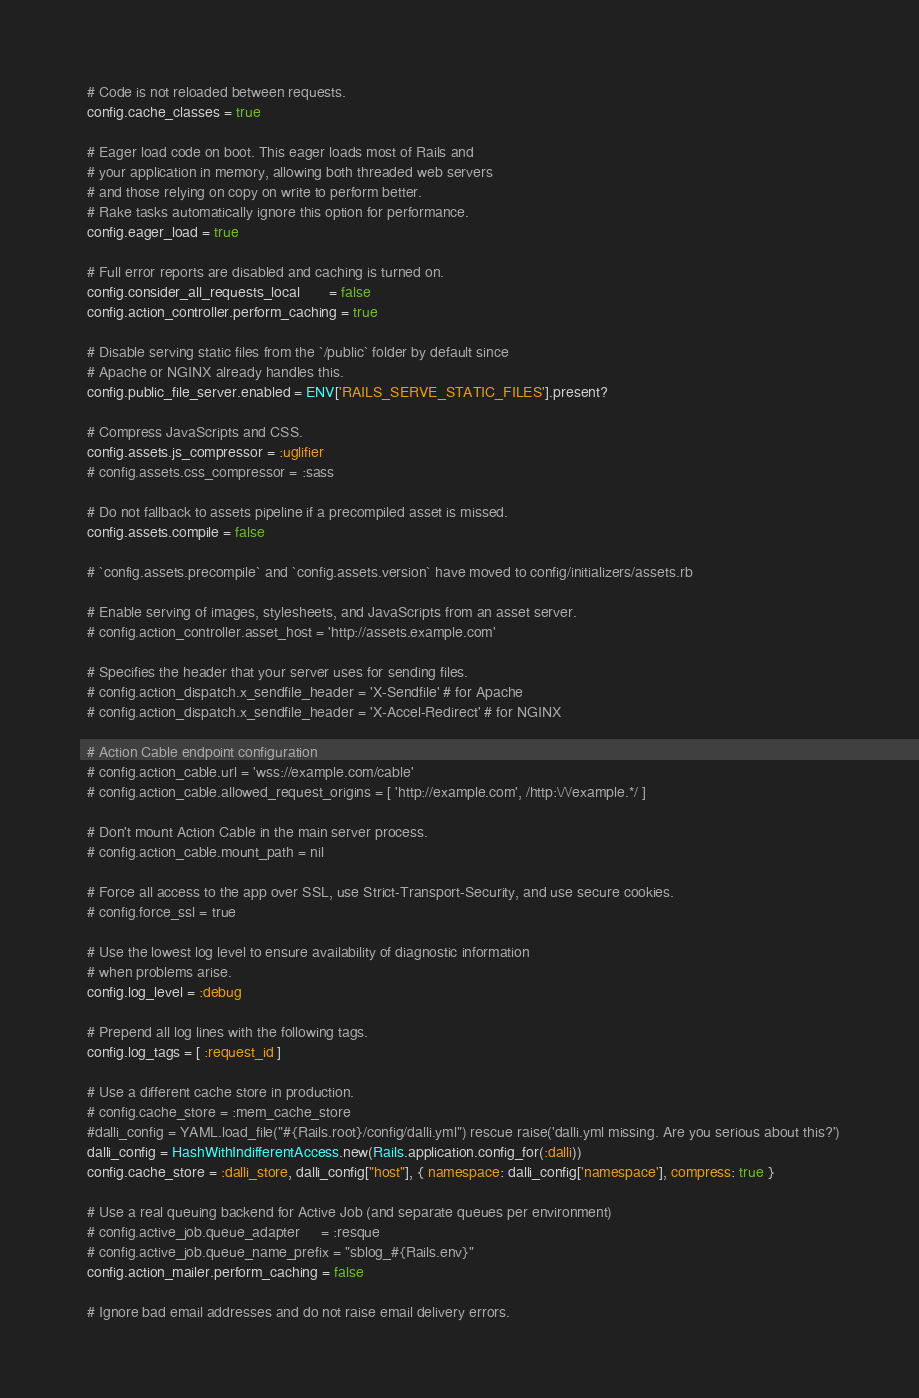<code> <loc_0><loc_0><loc_500><loc_500><_Ruby_>  # Code is not reloaded between requests.
  config.cache_classes = true

  # Eager load code on boot. This eager loads most of Rails and
  # your application in memory, allowing both threaded web servers
  # and those relying on copy on write to perform better.
  # Rake tasks automatically ignore this option for performance.
  config.eager_load = true

  # Full error reports are disabled and caching is turned on.
  config.consider_all_requests_local       = false
  config.action_controller.perform_caching = true

  # Disable serving static files from the `/public` folder by default since
  # Apache or NGINX already handles this.
  config.public_file_server.enabled = ENV['RAILS_SERVE_STATIC_FILES'].present?

  # Compress JavaScripts and CSS.
  config.assets.js_compressor = :uglifier
  # config.assets.css_compressor = :sass

  # Do not fallback to assets pipeline if a precompiled asset is missed.
  config.assets.compile = false

  # `config.assets.precompile` and `config.assets.version` have moved to config/initializers/assets.rb

  # Enable serving of images, stylesheets, and JavaScripts from an asset server.
  # config.action_controller.asset_host = 'http://assets.example.com'

  # Specifies the header that your server uses for sending files.
  # config.action_dispatch.x_sendfile_header = 'X-Sendfile' # for Apache
  # config.action_dispatch.x_sendfile_header = 'X-Accel-Redirect' # for NGINX

  # Action Cable endpoint configuration
  # config.action_cable.url = 'wss://example.com/cable'
  # config.action_cable.allowed_request_origins = [ 'http://example.com', /http:\/\/example.*/ ]

  # Don't mount Action Cable in the main server process.
  # config.action_cable.mount_path = nil

  # Force all access to the app over SSL, use Strict-Transport-Security, and use secure cookies.
  # config.force_ssl = true

  # Use the lowest log level to ensure availability of diagnostic information
  # when problems arise.
  config.log_level = :debug

  # Prepend all log lines with the following tags.
  config.log_tags = [ :request_id ]

  # Use a different cache store in production.
  # config.cache_store = :mem_cache_store
  #dalli_config = YAML.load_file("#{Rails.root}/config/dalli.yml") rescue raise('dalli.yml missing. Are you serious about this?')
  dalli_config = HashWithIndifferentAccess.new(Rails.application.config_for(:dalli))
  config.cache_store = :dalli_store, dalli_config["host"], { namespace: dalli_config['namespace'], compress: true }

  # Use a real queuing backend for Active Job (and separate queues per environment)
  # config.active_job.queue_adapter     = :resque
  # config.active_job.queue_name_prefix = "sblog_#{Rails.env}"
  config.action_mailer.perform_caching = false

  # Ignore bad email addresses and do not raise email delivery errors.</code> 